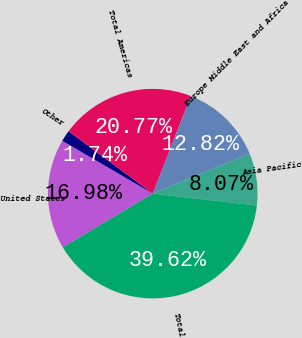Convert chart to OTSL. <chart><loc_0><loc_0><loc_500><loc_500><pie_chart><fcel>United States<fcel>Other<fcel>Total Americas<fcel>Europe Middle East and Africa<fcel>Asia Pacific<fcel>Total<nl><fcel>16.98%<fcel>1.74%<fcel>20.77%<fcel>12.82%<fcel>8.07%<fcel>39.62%<nl></chart> 